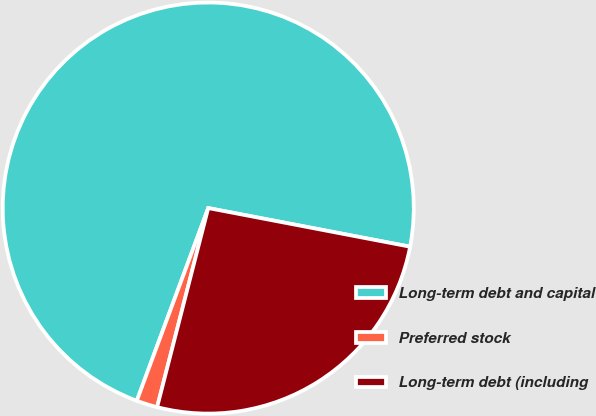Convert chart to OTSL. <chart><loc_0><loc_0><loc_500><loc_500><pie_chart><fcel>Long-term debt and capital<fcel>Preferred stock<fcel>Long-term debt (including<nl><fcel>72.36%<fcel>1.65%<fcel>25.99%<nl></chart> 